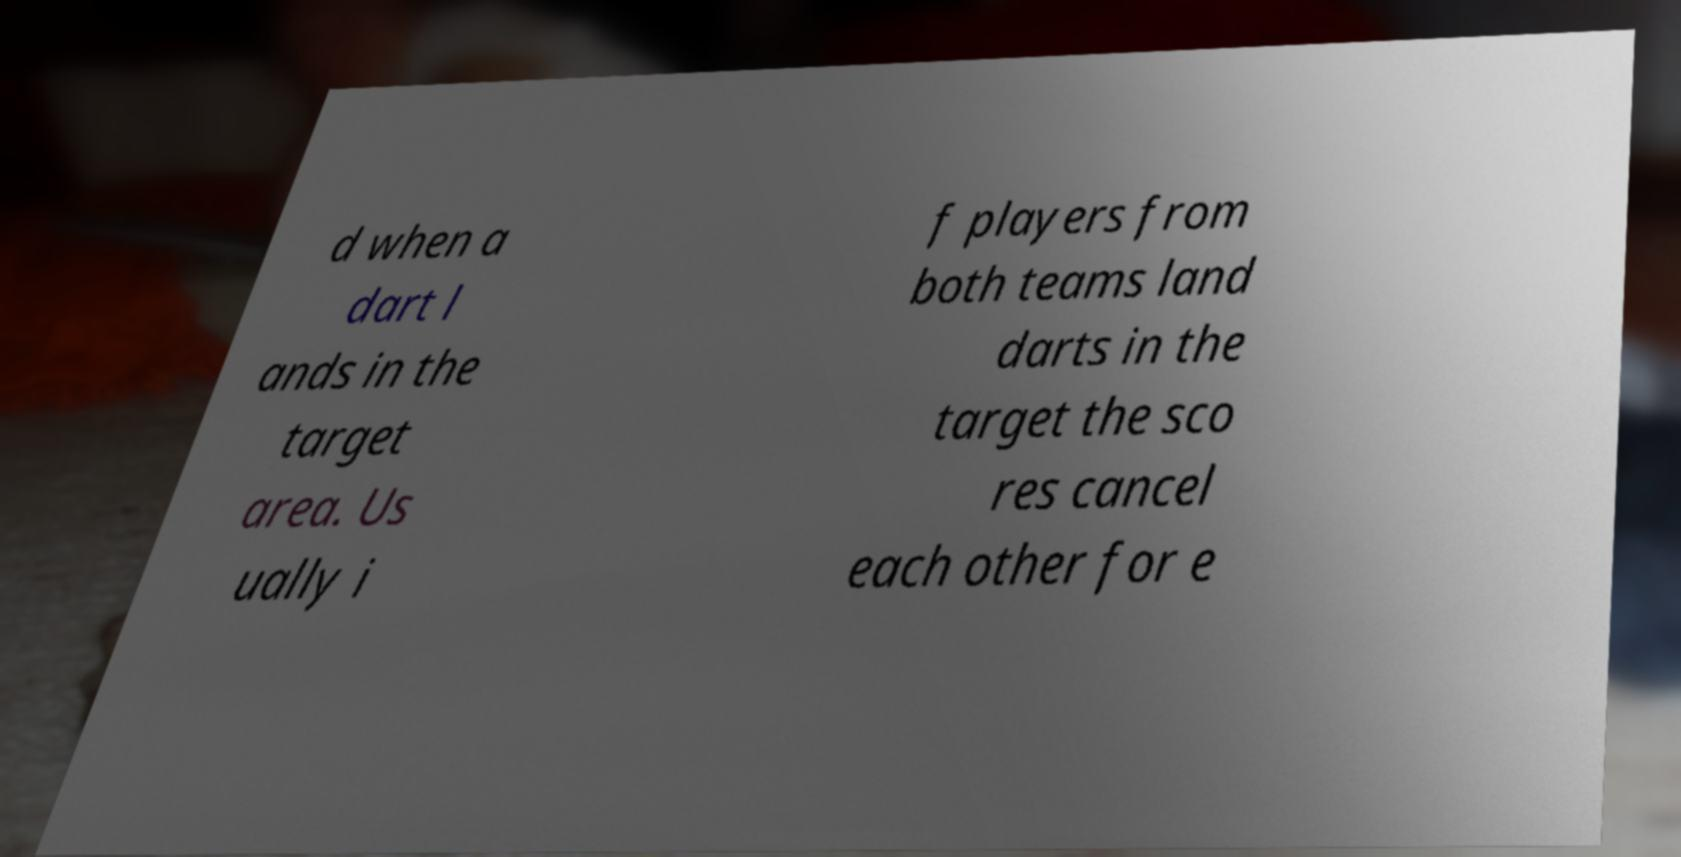Please identify and transcribe the text found in this image. d when a dart l ands in the target area. Us ually i f players from both teams land darts in the target the sco res cancel each other for e 